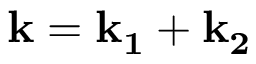Convert formula to latex. <formula><loc_0><loc_0><loc_500><loc_500>k = k _ { 1 } + k _ { 2 }</formula> 